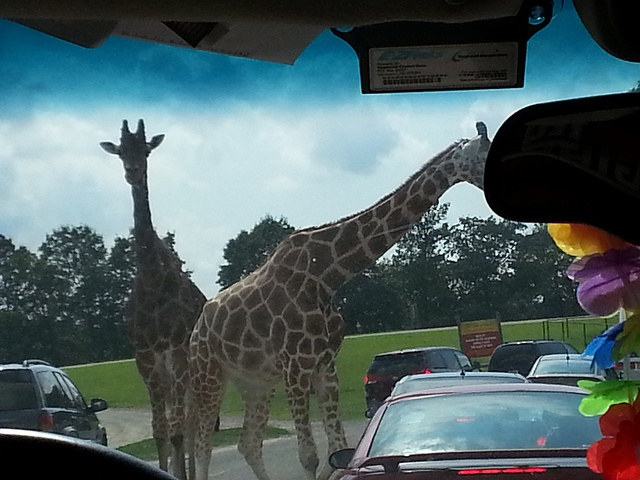Describe the objects in this image and their specific colors. I can see giraffe in black and gray tones, car in black, gray, darkgray, and lightblue tones, giraffe in black, gray, and darkblue tones, car in black, purple, and darkgray tones, and car in black, blue, gray, and darkblue tones in this image. 